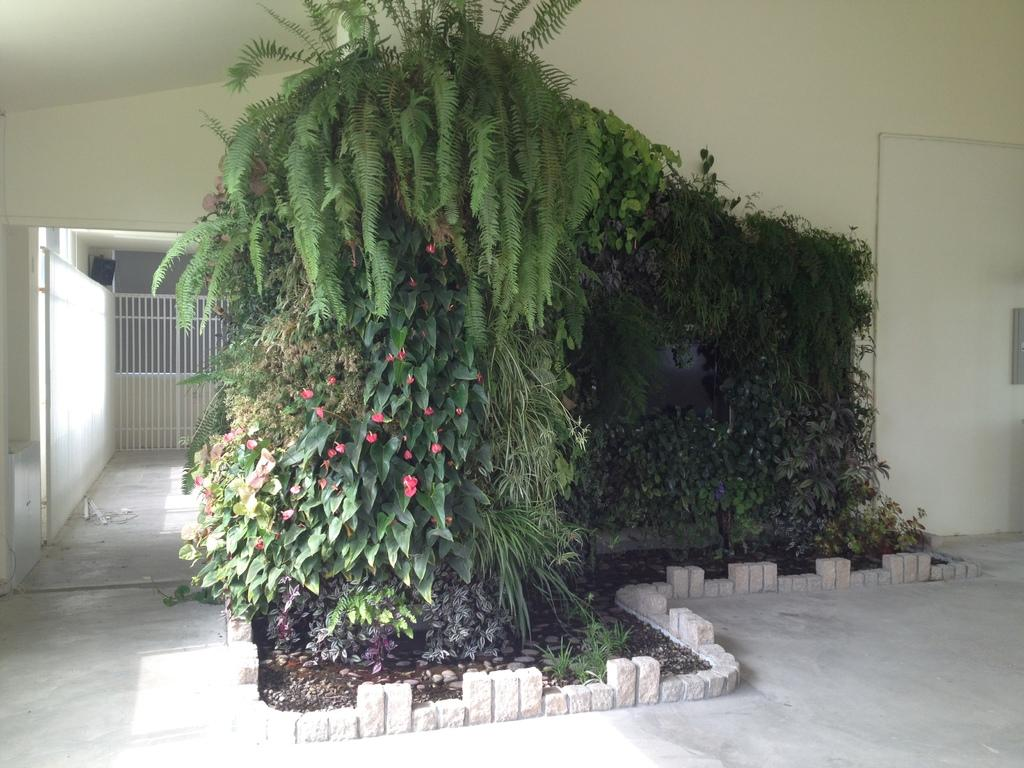What type of vegetation can be seen in the image? There are trees and plants in the image. What is surrounding the trees in the image? Stones are present around the trees. What can be seen in the background of the image? There is a door to a wall, an iron railing, and a black color object on the wall in the background of the image. What type of songs can be heard coming from the net in the image? There is no net present in the image, and therefore no songs can be heard from it. 